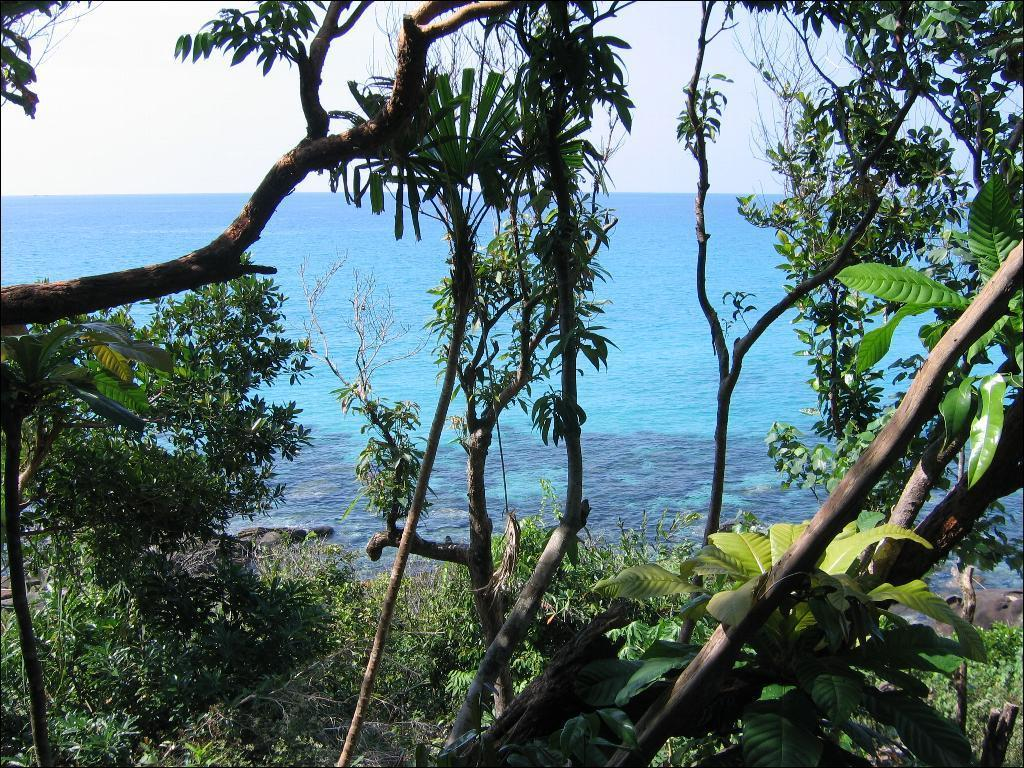What type of vegetation can be seen in the image? There are trees and plants in the image. How are the trees and plants arranged in the image? The trees and plants are arranged from left to right. What can be seen in the background of the image? There is water visible in the background of the image. What type of alley can be seen in the image? There is no alley present in the image; it features trees and plants arranged from left to right with water visible in the background. 